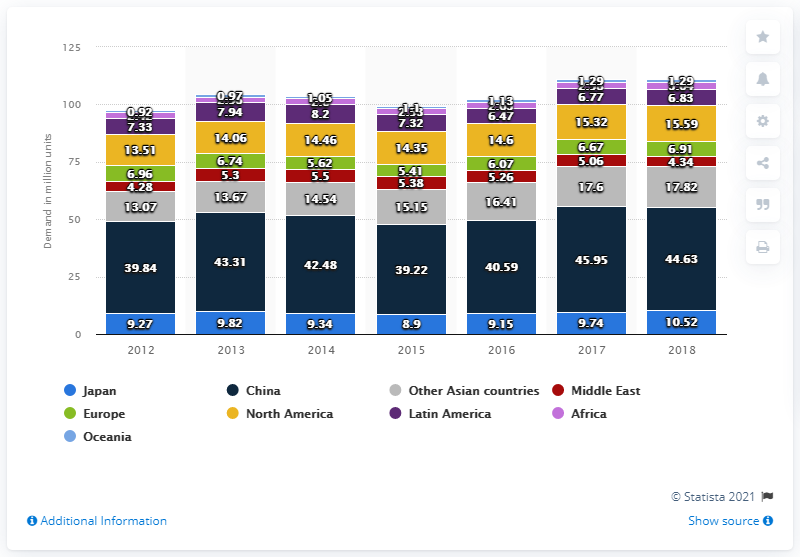Mention a couple of crucial points in this snapshot. The demand for air conditioners in the Chinese market in 2018 was 44.63. 